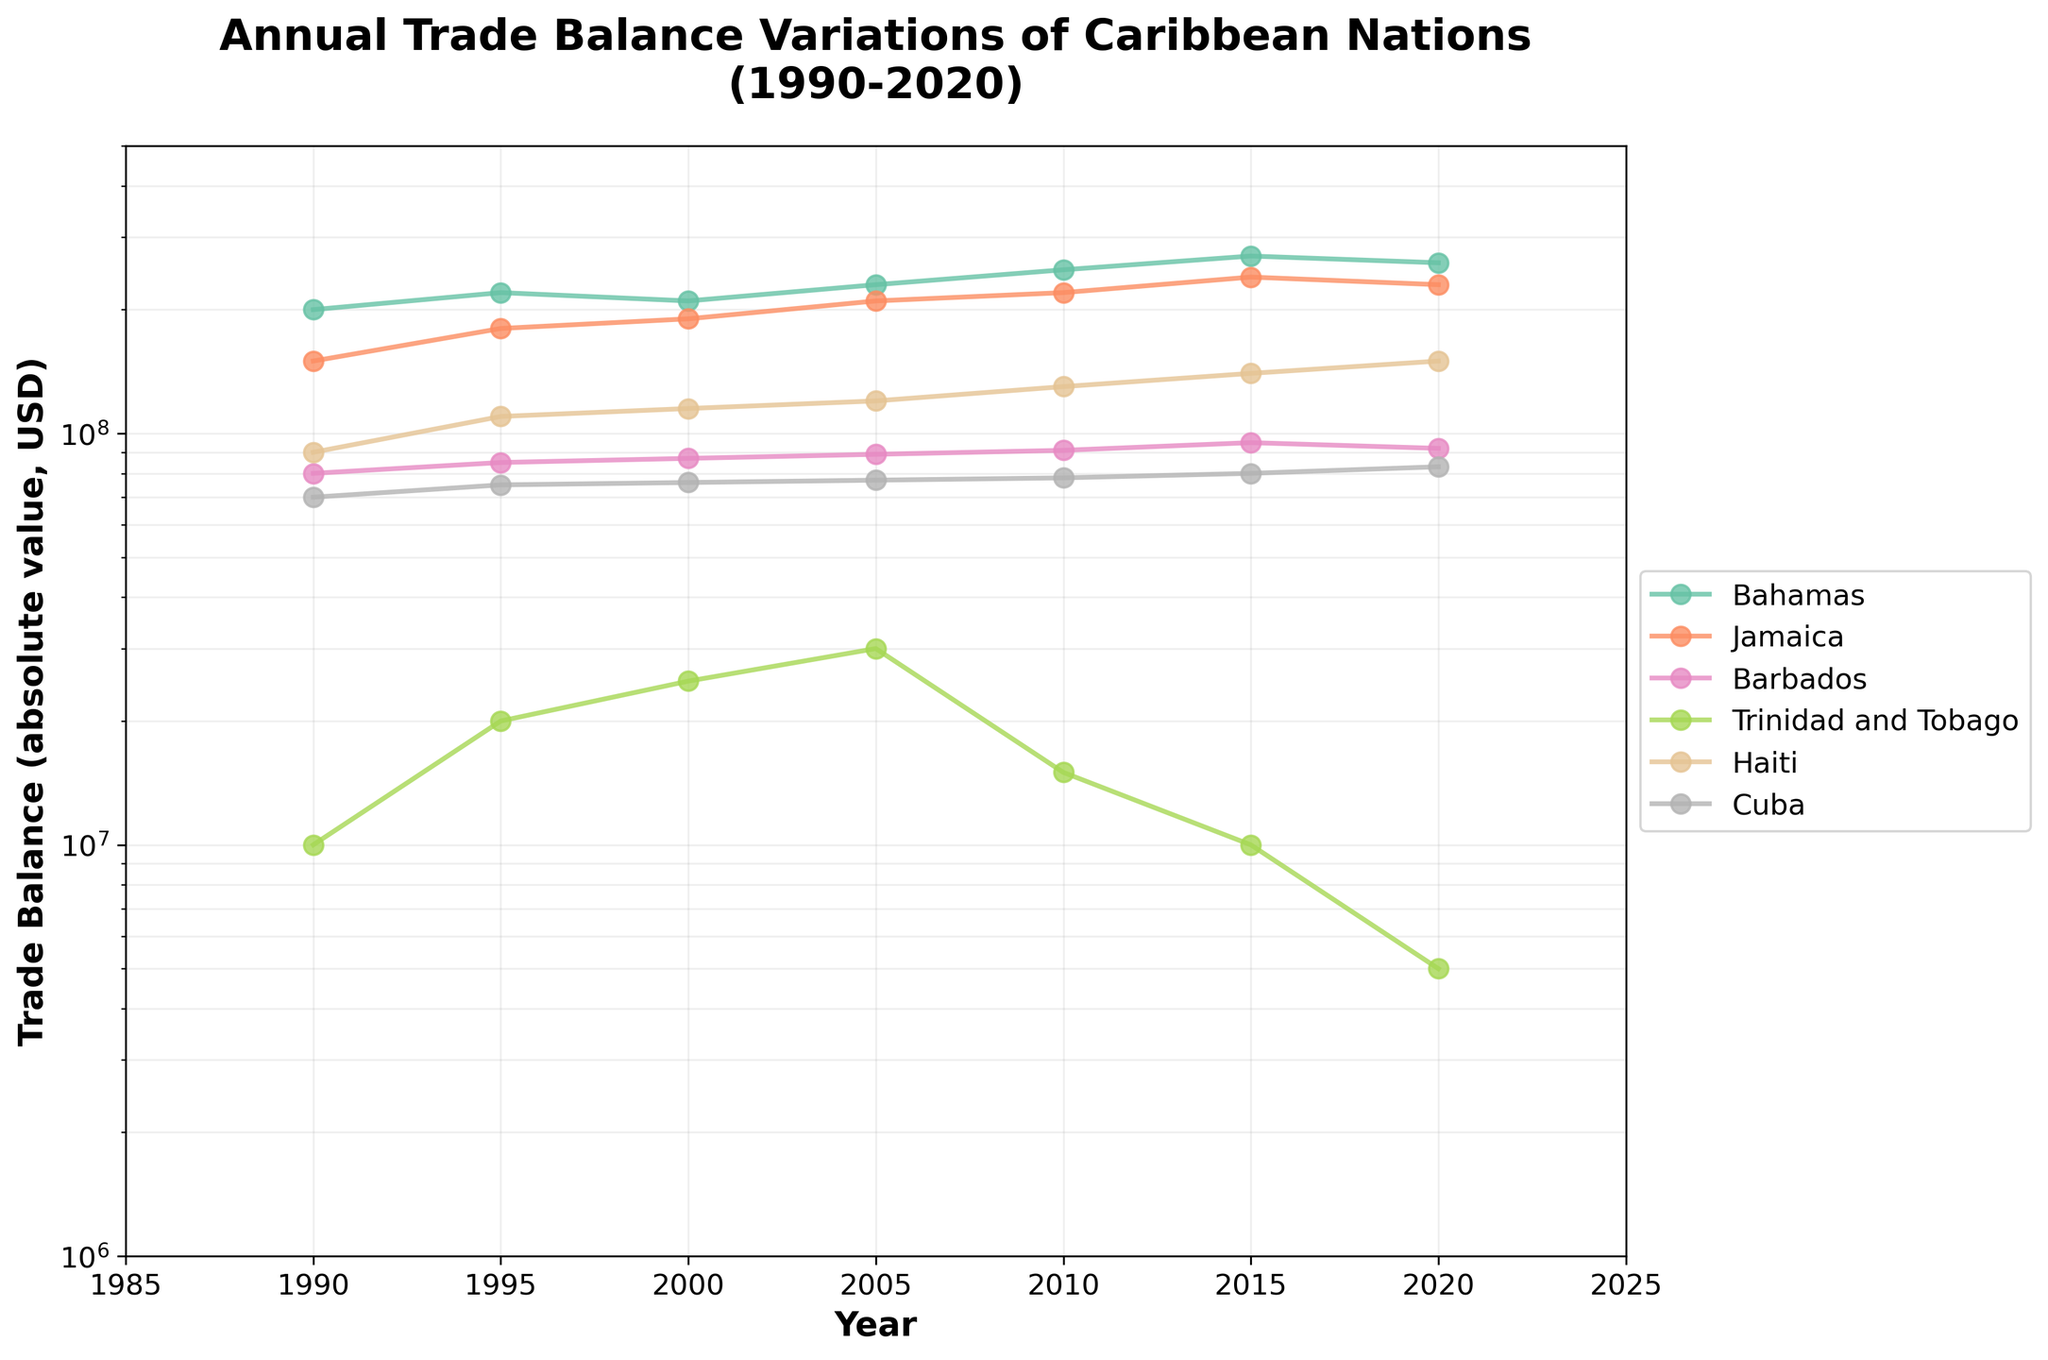What is the title of the figure? The title of the figure is displayed at the top and it summarizes what the plot is about. The title is "Annual Trade Balance Variations of Caribbean Nations (1990-2020)".
Answer: Annual Trade Balance Variations of Caribbean Nations (1990-2020) On which years does Trinidad and Tobago show a positive trade balance? By examining the line representing Trinidad and Tobago on the plot, the data points above the x-axis show the years with positive trade balances. Trinidad and Tobago has positive trade balances in 1990, 1995, 2000, and 2005.
Answer: 1990, 1995, 2000, 2005 Which country had the highest absolute trade balance in 2020? To determine this, look at the 2020 data points and compare their vertical positions. Trinidad and Tobago had the highest absolute trade balance, shown as the highest point (lowest deficit in this context) in 2020.
Answer: Trinidad and Tobago What is the trend shown by the Bahamas' trade balance from 1990 to 2020? Observing the line corresponding to the Bahamas from 1990 to 2020, the trade balance generally shows a downward trajectory, indicating an increasing trade deficit over time.
Answer: Increasing trade deficit How did Jamaica's trade balance change between 2015 and 2020? To answer this, compare the data points for Jamaica in 2015 and 2020. The 2020 trade balance is less negative than 2015, indicating a slight improvement.
Answer: Slightly improved Which country had the smallest trade deficit in 1990? Compare the trade balances for all countries in 1990 by looking at their respective points. Barbados had the smallest trade deficit in 1990.
Answer: Barbados What common pattern exists across all countries regarding their trade balances over the three decades? Examining the overall trends, most countries show an increasing trade deficit (more negative trade balance) over time, except Trinidad and Tobago, which has a fluctuating but generally positive trade balance in the earlier years
Answer: Increasing trade deficit Between which years did Trinidad and Tobago’s trade balance decrease the most? By observing the steepest decrease in the line representing Trinidad and Tobago, the largest drop occurs between 2010 and 2015.
Answer: 2010 and 2015 From the plot, can we say if the trade balance for Cuba is improving or deteriorating over the years? By examining the line for Cuba, it consistently trends downward, meaning the trade balance is deteriorating over the years.
Answer: Deteriorating 